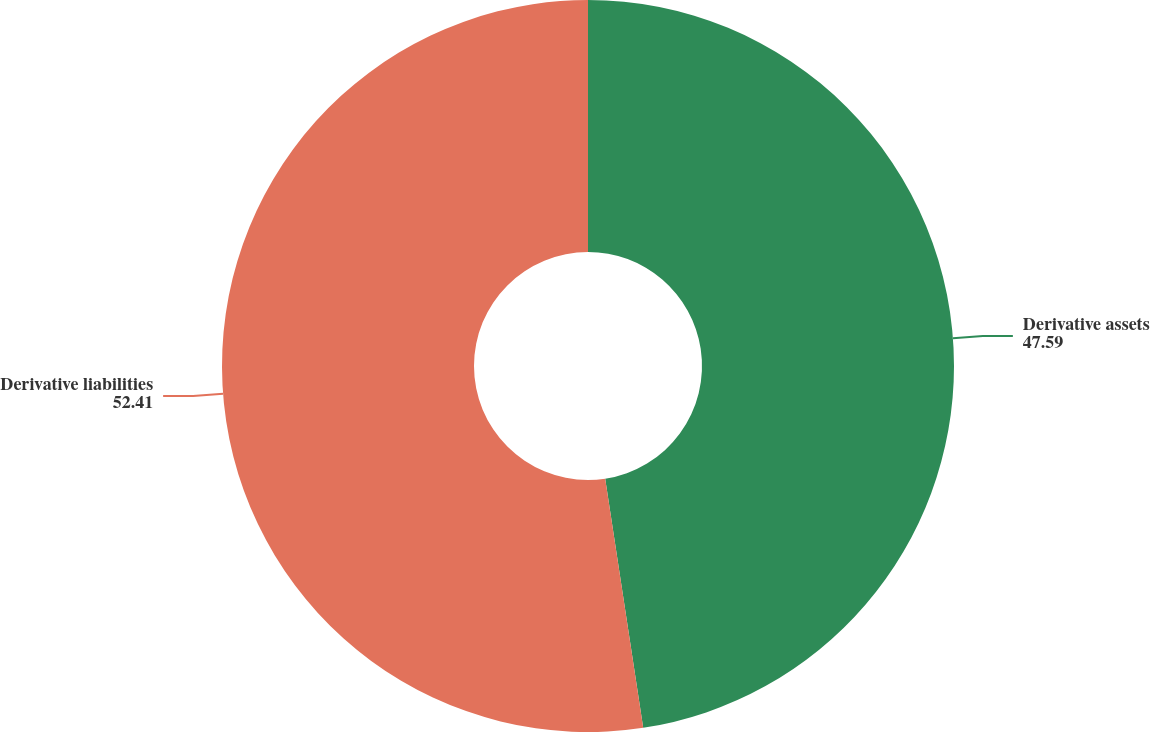Convert chart to OTSL. <chart><loc_0><loc_0><loc_500><loc_500><pie_chart><fcel>Derivative assets<fcel>Derivative liabilities<nl><fcel>47.59%<fcel>52.41%<nl></chart> 